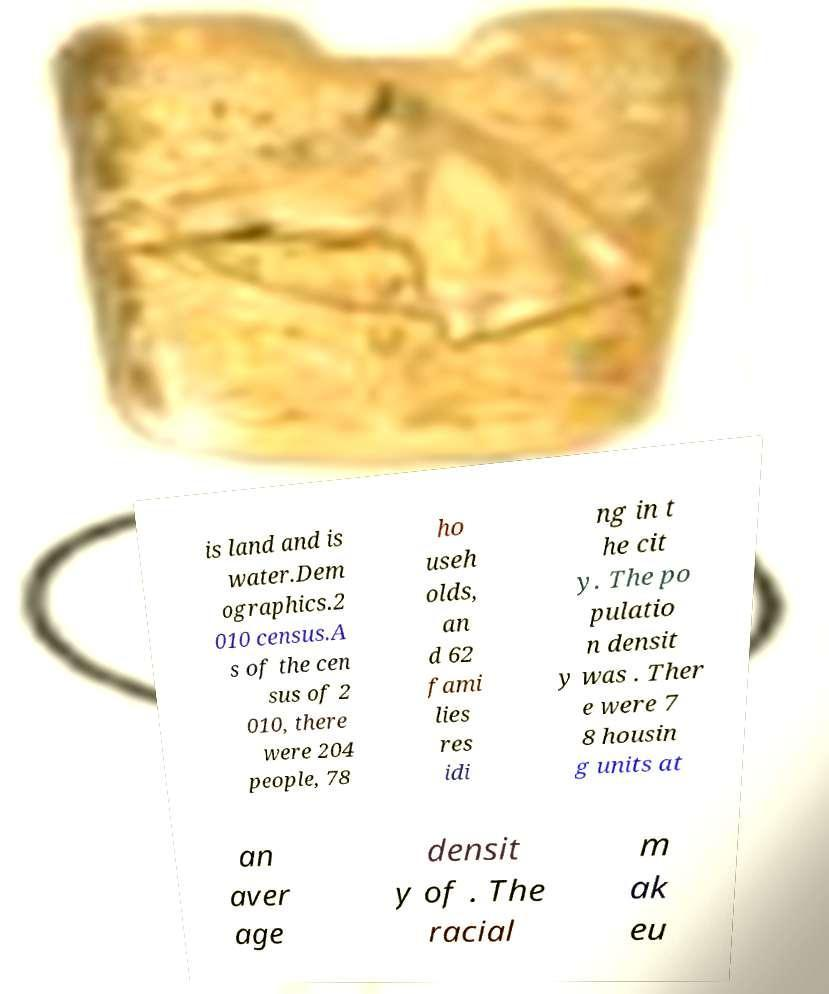Can you read and provide the text displayed in the image?This photo seems to have some interesting text. Can you extract and type it out for me? is land and is water.Dem ographics.2 010 census.A s of the cen sus of 2 010, there were 204 people, 78 ho useh olds, an d 62 fami lies res idi ng in t he cit y. The po pulatio n densit y was . Ther e were 7 8 housin g units at an aver age densit y of . The racial m ak eu 